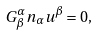<formula> <loc_0><loc_0><loc_500><loc_500>G ^ { \alpha } _ { \beta } n _ { \alpha } u ^ { \beta } = 0 ,</formula> 